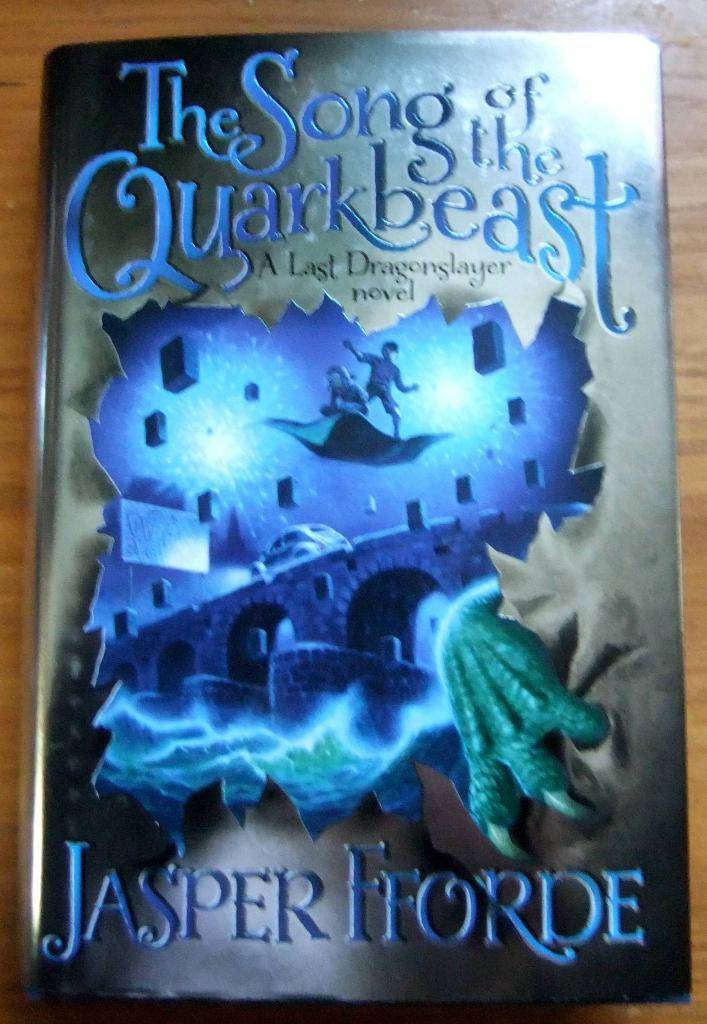<image>
Write a terse but informative summary of the picture. a book that was written by Jasper Forde 